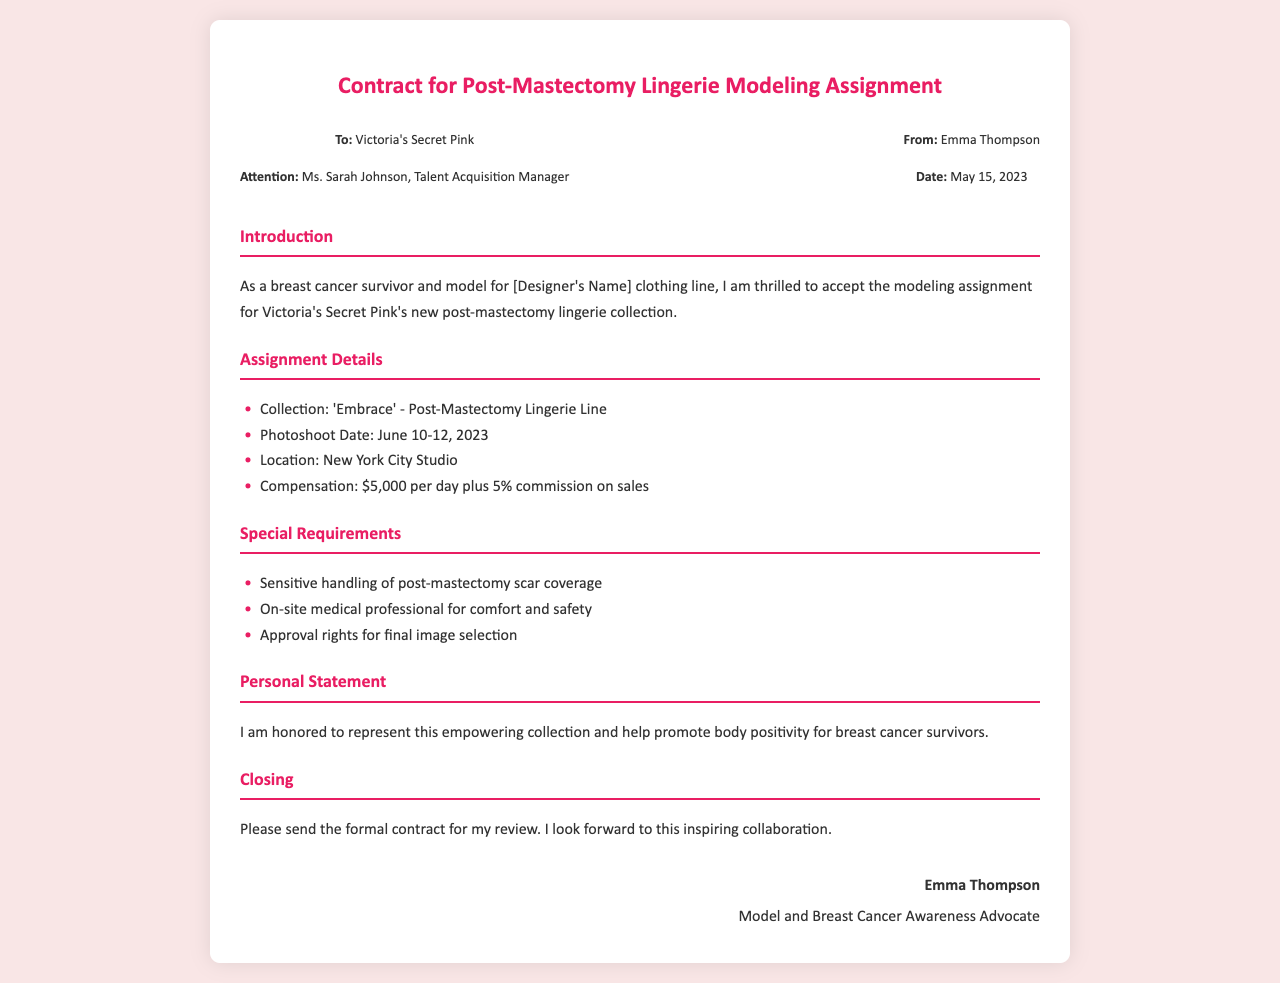what is the name of the collection? The collection name is highlighted in the "Assignment Details" section of the document, specifically named 'Embrace'.
Answer: 'Embrace' who is the Talent Acquisition Manager? The Talent Acquisition Manager's name is mentioned in the header details of the document.
Answer: Ms. Sarah Johnson when is the photoshoot scheduled? The photoshoot date is specified in the "Assignment Details" section of the document as June 10-12, 2023.
Answer: June 10-12, 2023 what is the daily compensation for the assignment? The compensation amount is listed in the "Assignment Details" section.
Answer: $5,000 per day what is required for on-set safety? The special requirements section mentions the need for an on-site medical professional for comfort and safety.
Answer: On-site medical professional how does Emma feel about representing the collection? Emma expresses her feelings in the "Personal Statement" section, indicating that she feels honored.
Answer: Honored what does Emma hope to promote through this collaboration? Emma's aspirations are mentioned in the "Personal Statement," where she emphasizes promoting body positivity.
Answer: Body positivity what must be obtained for final image selection? The special requirements section states that approval rights for final image selection must be obtained.
Answer: Approval rights what date was the contract sent? The contract date is stated in the header details of the document.
Answer: May 15, 2023 